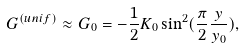Convert formula to latex. <formula><loc_0><loc_0><loc_500><loc_500>G ^ { ( u n i f ) } \approx G _ { 0 } = - \frac { 1 } { 2 } K _ { 0 } \sin ^ { 2 } ( \frac { \pi } { 2 } \frac { y } { y _ { 0 } } ) ,</formula> 